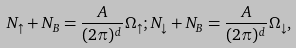Convert formula to latex. <formula><loc_0><loc_0><loc_500><loc_500>N _ { \uparrow } + N _ { B } = \frac { A } { ( 2 \pi ) ^ { d } } \Omega _ { \uparrow } ; N _ { \downarrow } + N _ { B } = \frac { A } { ( 2 \pi ) ^ { d } } \Omega _ { \downarrow } ,</formula> 